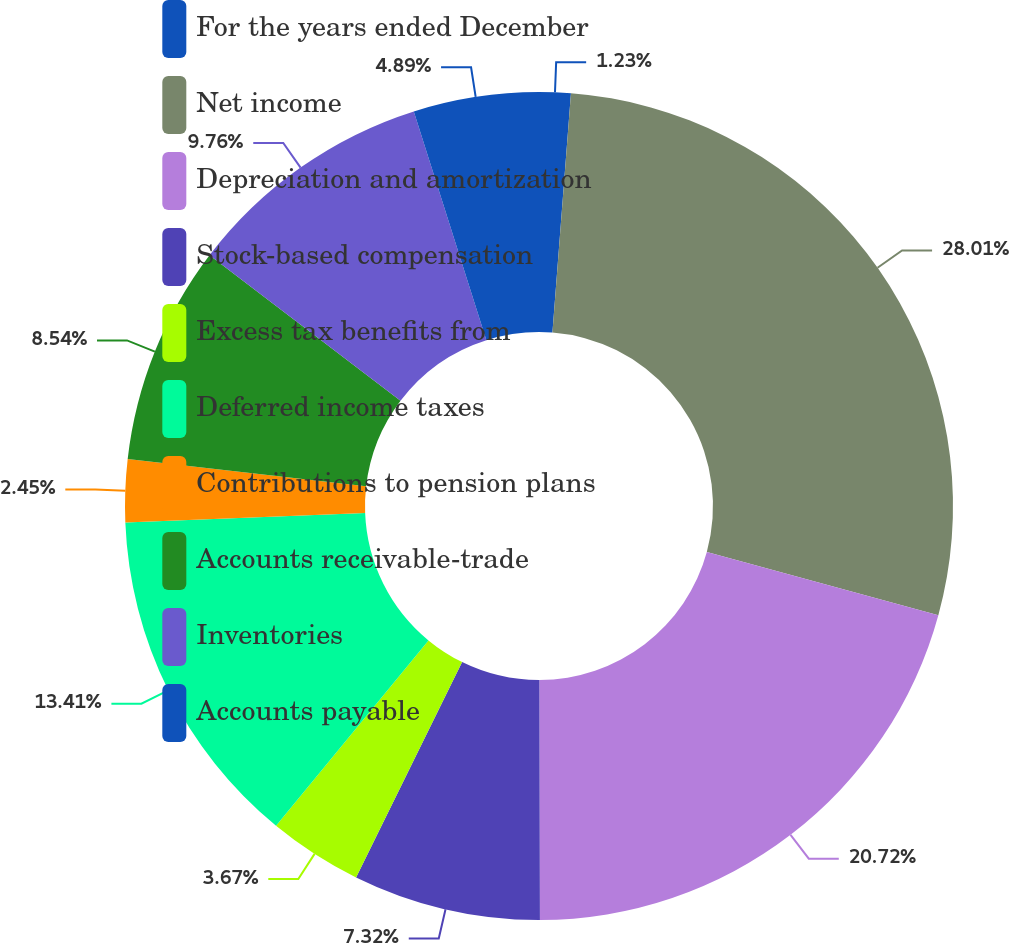Convert chart. <chart><loc_0><loc_0><loc_500><loc_500><pie_chart><fcel>For the years ended December<fcel>Net income<fcel>Depreciation and amortization<fcel>Stock-based compensation<fcel>Excess tax benefits from<fcel>Deferred income taxes<fcel>Contributions to pension plans<fcel>Accounts receivable-trade<fcel>Inventories<fcel>Accounts payable<nl><fcel>1.23%<fcel>28.02%<fcel>20.72%<fcel>7.32%<fcel>3.67%<fcel>13.41%<fcel>2.45%<fcel>8.54%<fcel>9.76%<fcel>4.89%<nl></chart> 